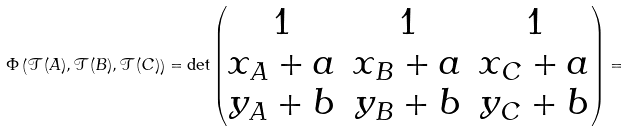Convert formula to latex. <formula><loc_0><loc_0><loc_500><loc_500>\Phi \left ( \mathcal { T } ( A ) , \mathcal { T } ( B ) , \mathcal { T } ( C ) \right ) = \det \begin{pmatrix} 1 & 1 & 1 \\ x _ { A } + a & x _ { B } + a & x _ { C } + a \\ y _ { A } + b & y _ { B } + b & y _ { C } + b \end{pmatrix} =</formula> 